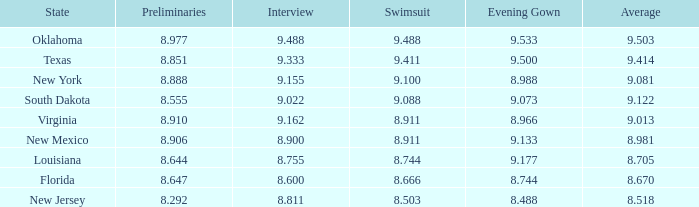977? 9.533. 